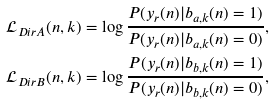Convert formula to latex. <formula><loc_0><loc_0><loc_500><loc_500>\mathcal { L } _ { D i r A } ( n , k ) = \log \frac { P ( y _ { r } ( n ) | b _ { a , k } ( n ) = 1 ) } { P ( y _ { r } ( n ) | b _ { a , k } ( n ) = 0 ) } , \\ \mathcal { L } _ { D i r B } ( n , k ) = \log \frac { P ( y _ { r } ( n ) | b _ { b , k } ( n ) = 1 ) } { P ( y _ { r } ( n ) | b _ { b , k } ( n ) = 0 ) } ,</formula> 